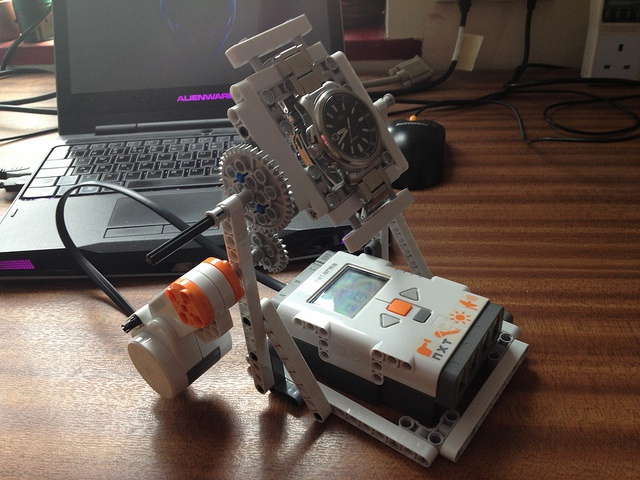Describe the objects in this image and their specific colors. I can see dining table in tan, maroon, black, and ivory tones, laptop in tan, gray, black, white, and darkgray tones, mouse in tan, black, gray, darkgray, and maroon tones, and clock in tan, black, and gray tones in this image. 